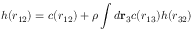<formula> <loc_0><loc_0><loc_500><loc_500>h ( r _ { 1 2 } ) = c ( r _ { 1 2 } ) + \rho \int d r _ { 3 } c ( r _ { 1 3 } ) h ( r _ { 3 2 } )</formula> 